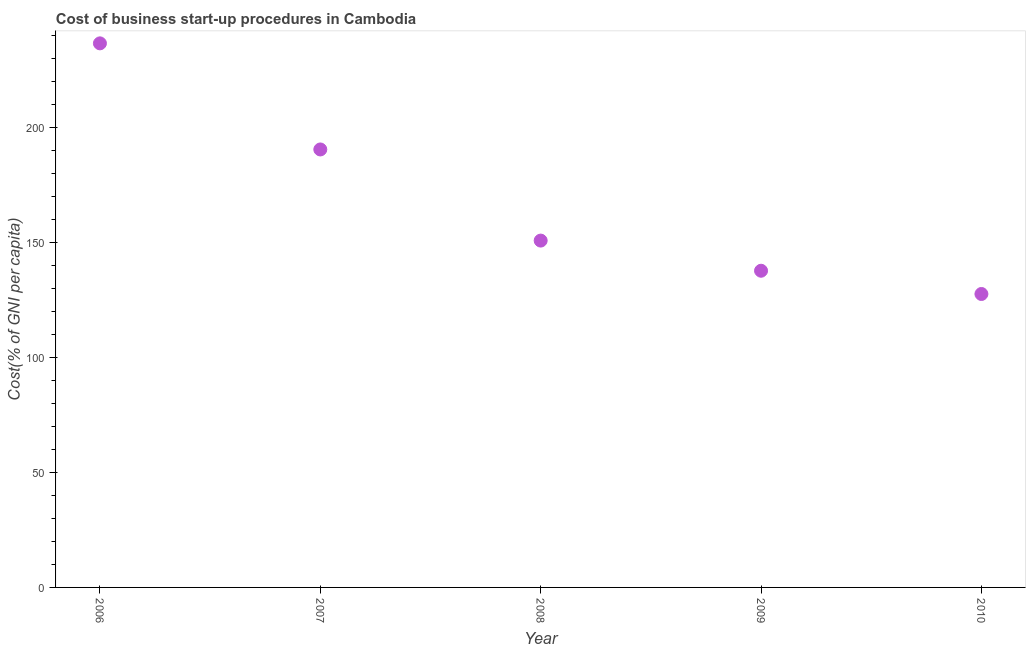What is the cost of business startup procedures in 2008?
Your answer should be very brief. 150.7. Across all years, what is the maximum cost of business startup procedures?
Offer a very short reply. 236.4. Across all years, what is the minimum cost of business startup procedures?
Your answer should be compact. 127.5. In which year was the cost of business startup procedures maximum?
Offer a very short reply. 2006. What is the sum of the cost of business startup procedures?
Offer a terse response. 842.5. What is the difference between the cost of business startup procedures in 2006 and 2007?
Offer a terse response. 46.1. What is the average cost of business startup procedures per year?
Offer a terse response. 168.5. What is the median cost of business startup procedures?
Offer a very short reply. 150.7. In how many years, is the cost of business startup procedures greater than 90 %?
Keep it short and to the point. 5. Do a majority of the years between 2009 and 2010 (inclusive) have cost of business startup procedures greater than 190 %?
Offer a terse response. No. What is the ratio of the cost of business startup procedures in 2006 to that in 2009?
Offer a terse response. 1.72. Is the cost of business startup procedures in 2006 less than that in 2010?
Ensure brevity in your answer.  No. Is the difference between the cost of business startup procedures in 2007 and 2009 greater than the difference between any two years?
Provide a succinct answer. No. What is the difference between the highest and the second highest cost of business startup procedures?
Your response must be concise. 46.1. Is the sum of the cost of business startup procedures in 2008 and 2009 greater than the maximum cost of business startup procedures across all years?
Offer a very short reply. Yes. What is the difference between the highest and the lowest cost of business startup procedures?
Offer a very short reply. 108.9. In how many years, is the cost of business startup procedures greater than the average cost of business startup procedures taken over all years?
Offer a terse response. 2. How many dotlines are there?
Offer a very short reply. 1. What is the difference between two consecutive major ticks on the Y-axis?
Offer a terse response. 50. Does the graph contain grids?
Your answer should be compact. No. What is the title of the graph?
Provide a short and direct response. Cost of business start-up procedures in Cambodia. What is the label or title of the X-axis?
Your response must be concise. Year. What is the label or title of the Y-axis?
Your answer should be very brief. Cost(% of GNI per capita). What is the Cost(% of GNI per capita) in 2006?
Provide a short and direct response. 236.4. What is the Cost(% of GNI per capita) in 2007?
Your response must be concise. 190.3. What is the Cost(% of GNI per capita) in 2008?
Your response must be concise. 150.7. What is the Cost(% of GNI per capita) in 2009?
Your response must be concise. 137.6. What is the Cost(% of GNI per capita) in 2010?
Ensure brevity in your answer.  127.5. What is the difference between the Cost(% of GNI per capita) in 2006 and 2007?
Provide a succinct answer. 46.1. What is the difference between the Cost(% of GNI per capita) in 2006 and 2008?
Make the answer very short. 85.7. What is the difference between the Cost(% of GNI per capita) in 2006 and 2009?
Offer a terse response. 98.8. What is the difference between the Cost(% of GNI per capita) in 2006 and 2010?
Give a very brief answer. 108.9. What is the difference between the Cost(% of GNI per capita) in 2007 and 2008?
Ensure brevity in your answer.  39.6. What is the difference between the Cost(% of GNI per capita) in 2007 and 2009?
Ensure brevity in your answer.  52.7. What is the difference between the Cost(% of GNI per capita) in 2007 and 2010?
Make the answer very short. 62.8. What is the difference between the Cost(% of GNI per capita) in 2008 and 2010?
Ensure brevity in your answer.  23.2. What is the ratio of the Cost(% of GNI per capita) in 2006 to that in 2007?
Give a very brief answer. 1.24. What is the ratio of the Cost(% of GNI per capita) in 2006 to that in 2008?
Provide a succinct answer. 1.57. What is the ratio of the Cost(% of GNI per capita) in 2006 to that in 2009?
Keep it short and to the point. 1.72. What is the ratio of the Cost(% of GNI per capita) in 2006 to that in 2010?
Your answer should be very brief. 1.85. What is the ratio of the Cost(% of GNI per capita) in 2007 to that in 2008?
Provide a succinct answer. 1.26. What is the ratio of the Cost(% of GNI per capita) in 2007 to that in 2009?
Your answer should be compact. 1.38. What is the ratio of the Cost(% of GNI per capita) in 2007 to that in 2010?
Give a very brief answer. 1.49. What is the ratio of the Cost(% of GNI per capita) in 2008 to that in 2009?
Keep it short and to the point. 1.09. What is the ratio of the Cost(% of GNI per capita) in 2008 to that in 2010?
Give a very brief answer. 1.18. What is the ratio of the Cost(% of GNI per capita) in 2009 to that in 2010?
Your answer should be very brief. 1.08. 